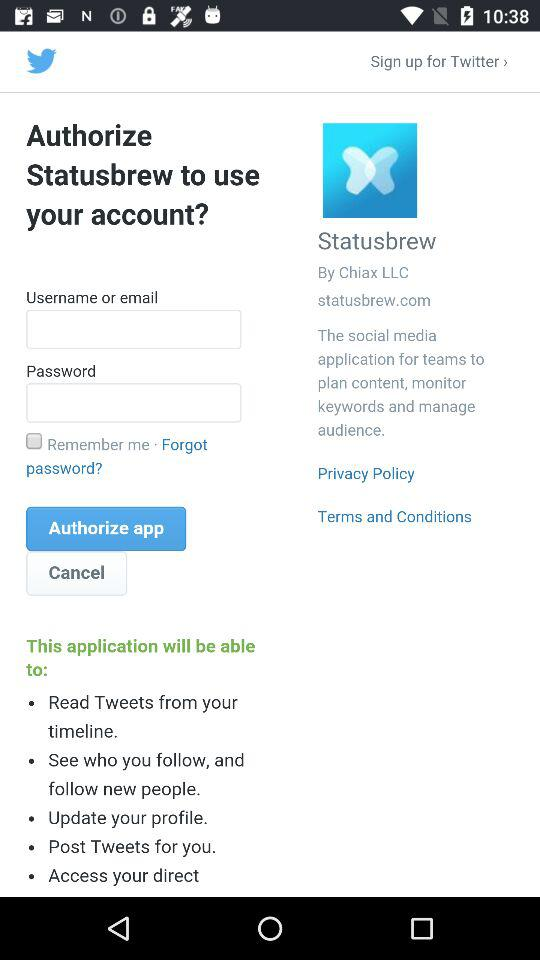What are the requirements to authorize the application? The requirements to authorize the application are "Username or email" and "Password". 